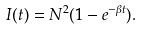Convert formula to latex. <formula><loc_0><loc_0><loc_500><loc_500>I ( t ) = N ^ { 2 } ( 1 - e ^ { - \beta t } ) .</formula> 